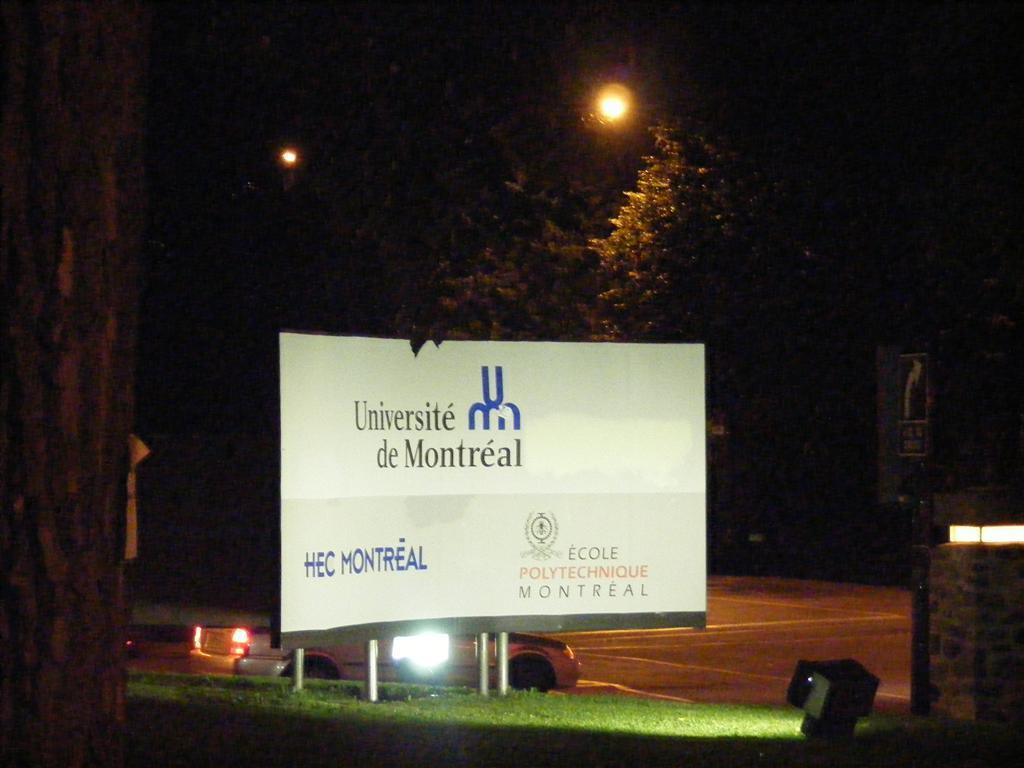<image>
Provide a brief description of the given image. The billboard for Universite de Montreal is brightly lit in a dark parking lot 